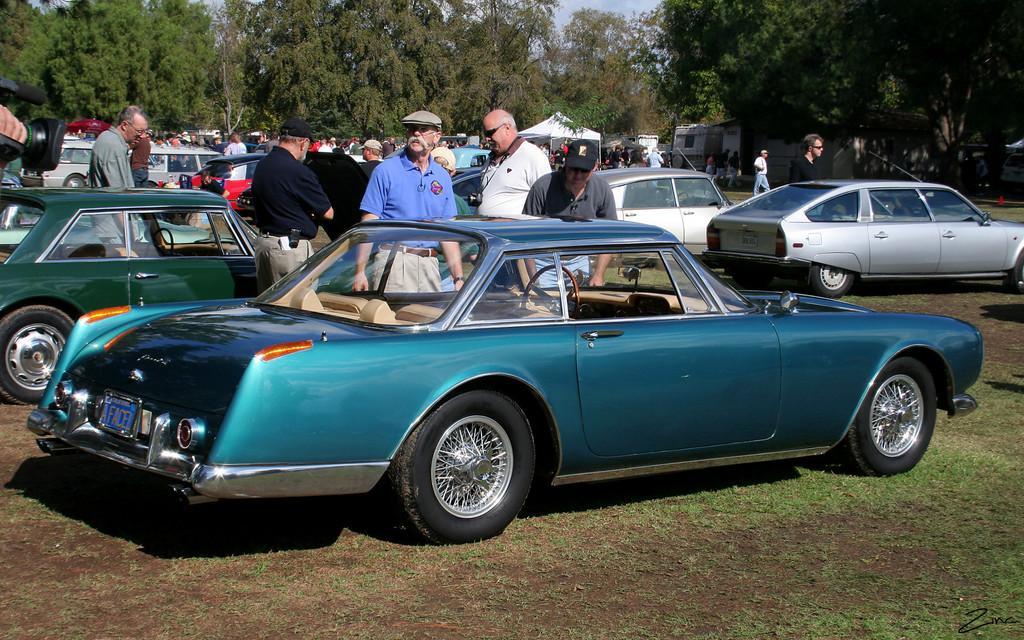Could you give a brief overview of what you see in this image? There is a violet color car, parked on the grass on the ground, near persons who are standing on the ground. In the background, there are vehicles parked, there are persons, there are trees and there is a blue sky. 